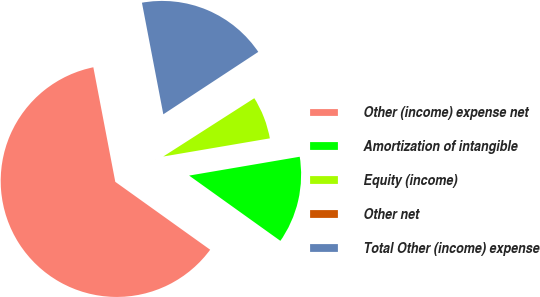<chart> <loc_0><loc_0><loc_500><loc_500><pie_chart><fcel>Other (income) expense net<fcel>Amortization of intangible<fcel>Equity (income)<fcel>Other net<fcel>Total Other (income) expense<nl><fcel>62.11%<fcel>12.57%<fcel>6.38%<fcel>0.19%<fcel>18.76%<nl></chart> 